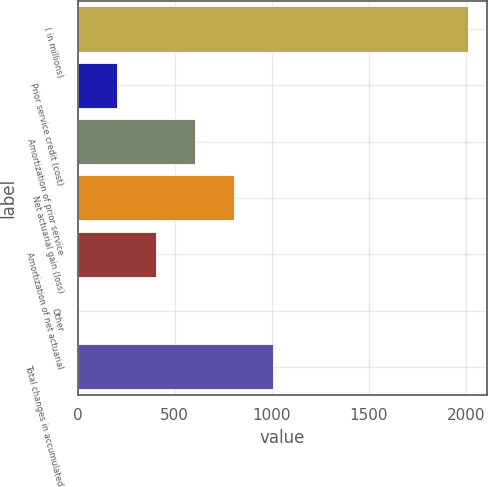Convert chart to OTSL. <chart><loc_0><loc_0><loc_500><loc_500><bar_chart><fcel>( in millions)<fcel>Prior service credit (cost)<fcel>Amortization of prior service<fcel>Net actuarial gain (loss)<fcel>Amortization of net actuarial<fcel>Other<fcel>Total changes in accumulated<nl><fcel>2010<fcel>201.29<fcel>603.23<fcel>804.2<fcel>402.26<fcel>0.32<fcel>1005.17<nl></chart> 